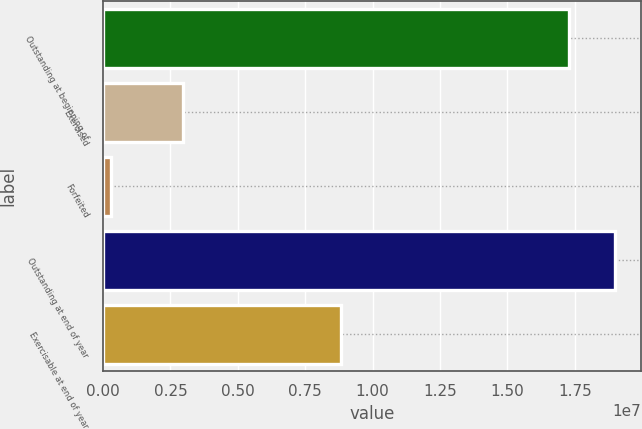Convert chart. <chart><loc_0><loc_0><loc_500><loc_500><bar_chart><fcel>Outstanding at beginning of<fcel>Exercised<fcel>Forfeited<fcel>Outstanding at end of year<fcel>Exercisable at end of year<nl><fcel>1.7306e+07<fcel>2.95115e+06<fcel>301544<fcel>1.90074e+07<fcel>8.82952e+06<nl></chart> 